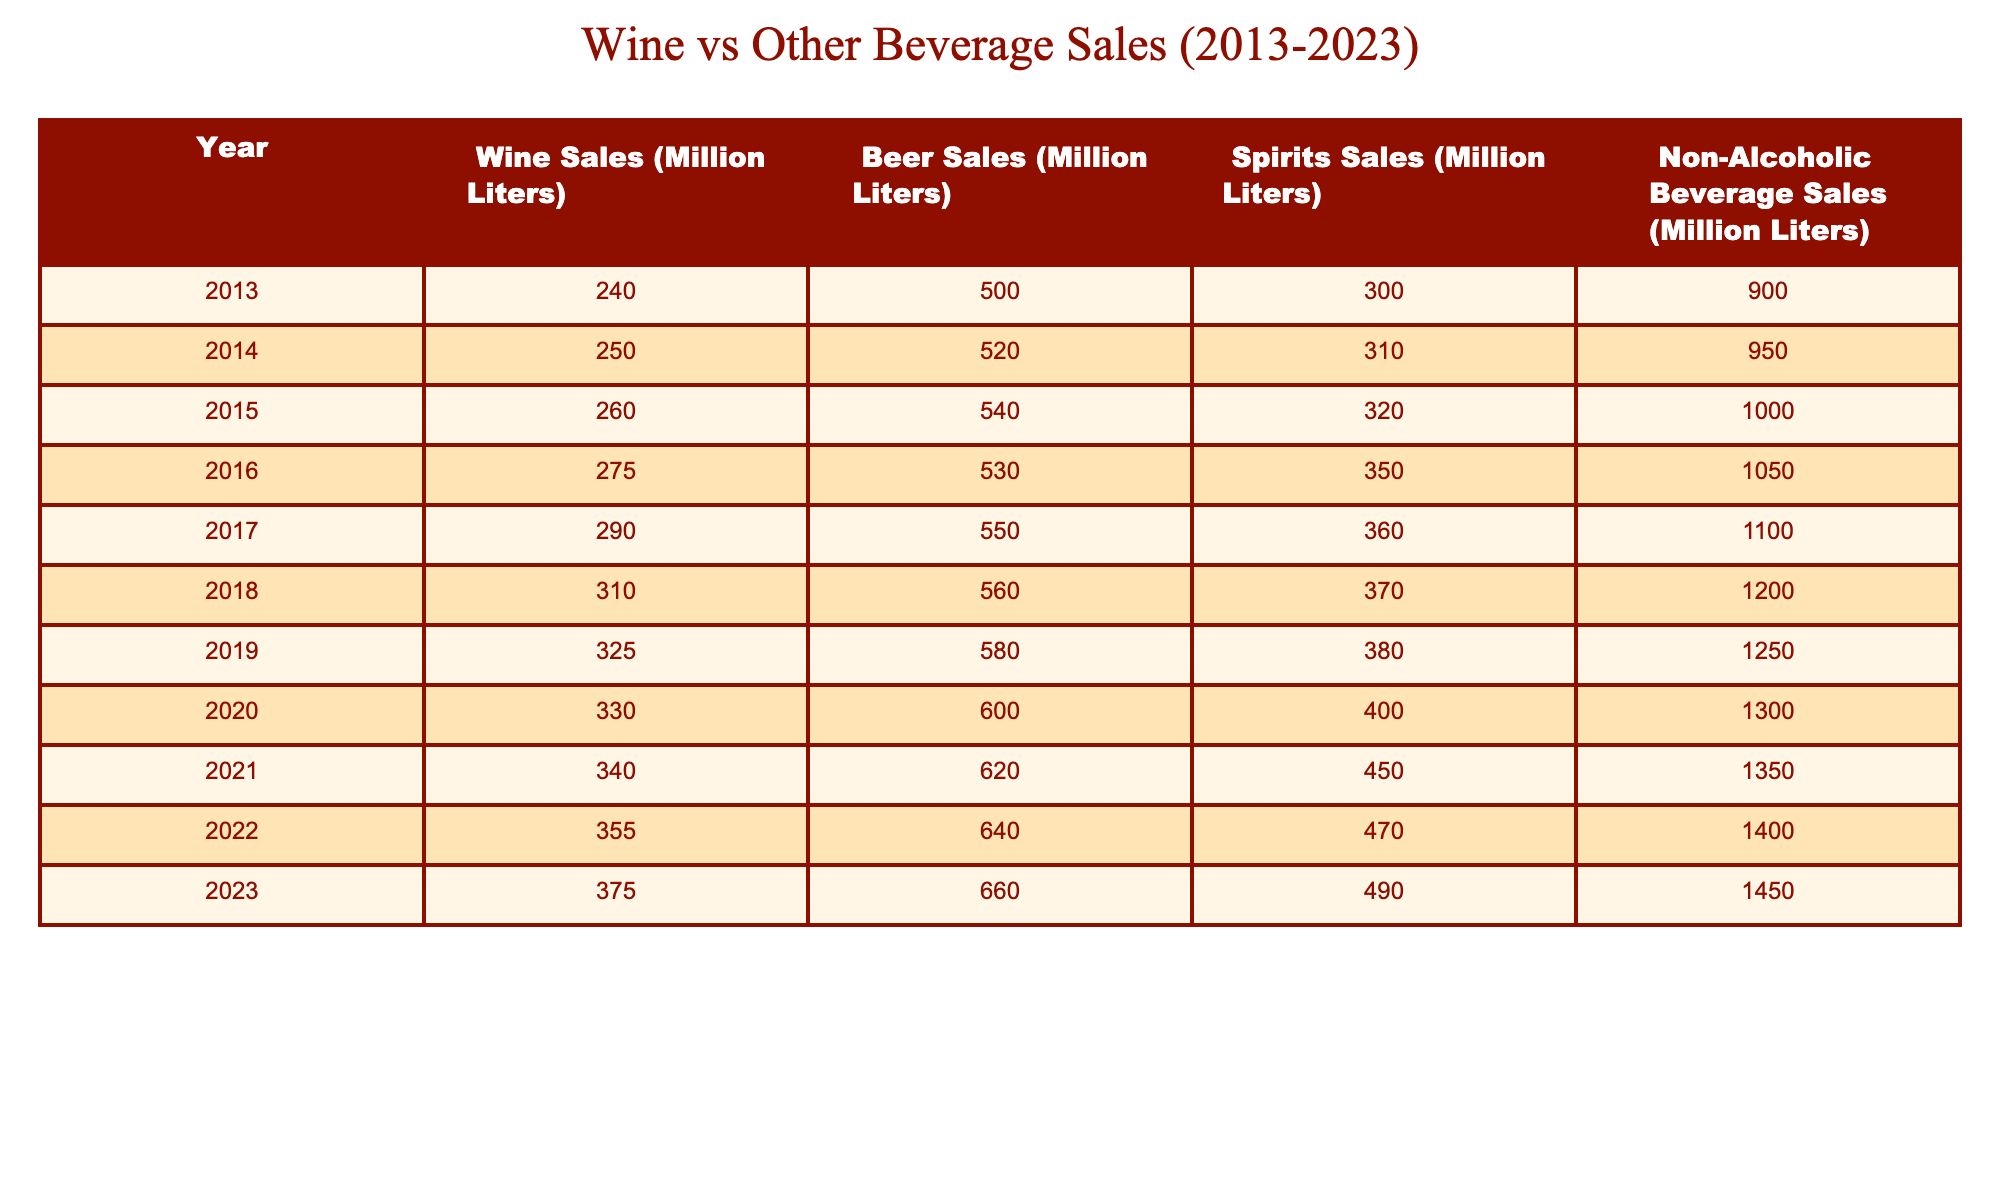What were the wine sales in 2023? According to the table, the wine sales in 2023 were recorded as 375 million liters.
Answer: 375 million liters What is the total beer sales from 2013 to 2023? To find the total beer sales, sum the annual sales: 500 + 520 + 540 + 530 + 550 + 560 + 580 + 600 + 620 + 640 + 660 = 6,300 million liters.
Answer: 6,300 million liters Did wine sales ever exceed 300 million liters between 2013 and 2023? By examining the table, it is evident that wine sales exceeded 300 million liters starting from the year 2018.
Answer: Yes What was the increase in spirits sales from 2013 to 2023? To determine the increase, subtract the spirits sales in 2013 from those in 2023: 490 - 300 = 190 million liters.
Answer: 190 million liters What year saw the highest wine sales growth compared to the previous year? The greatest increase in wine sales occurred from 2022 to 2023, with sales growing from 355 to 375 million liters, a difference of 20 million liters.
Answer: 2023 What was average non-alcoholic beverage sales over the decade? Calculate the average by summing the annual sales (900 + 950 + 1000 + 1050 + 1100 + 1200 + 1250 + 1300 + 1350 + 1400 + 1450) = 13,800 million liters, and then divide by 11 years, which gives an average of 1,254.55 million liters.
Answer: Approximately 1,254.55 million liters Which year had the lowest wine sales, and what was the amount? Looking at the table, the lowest wine sales occurred in 2013 with 240 million liters.
Answer: 2013, 240 million liters What was the percentage increase in wine sales from 2013 to 2023? Calculate the percentage increase using the formula [(375 - 240) / 240] * 100 = 56.25%.
Answer: 56.25% Was the amount of non-alcoholic beverage sales greater than the spirits sales in every year? Comparing the two, non-alcoholic beverage sales exceeded spirits sales each year from 2013 to 2023.
Answer: Yes What was the total volume of wine and spirits sales together in 2021? Adding wine and spirits sales for 2021 gives 340 (wine) + 450 (spirits) = 790 million liters.
Answer: 790 million liters How do the average wine sales from 2013 to 2017 compare to the average from 2018 to 2023? The average wine sales from 2013 to 2017 is (240 + 250 + 260 + 275 + 290) / 5 = 263 million liters. The average from 2018 to 2023 is (310 + 325 + 330 + 340 + 355 + 375) / 6 = 344.17 million liters. Since 344.17 > 263, the later period has higher average sales.
Answer: The average from 2018 to 2023 is higher 